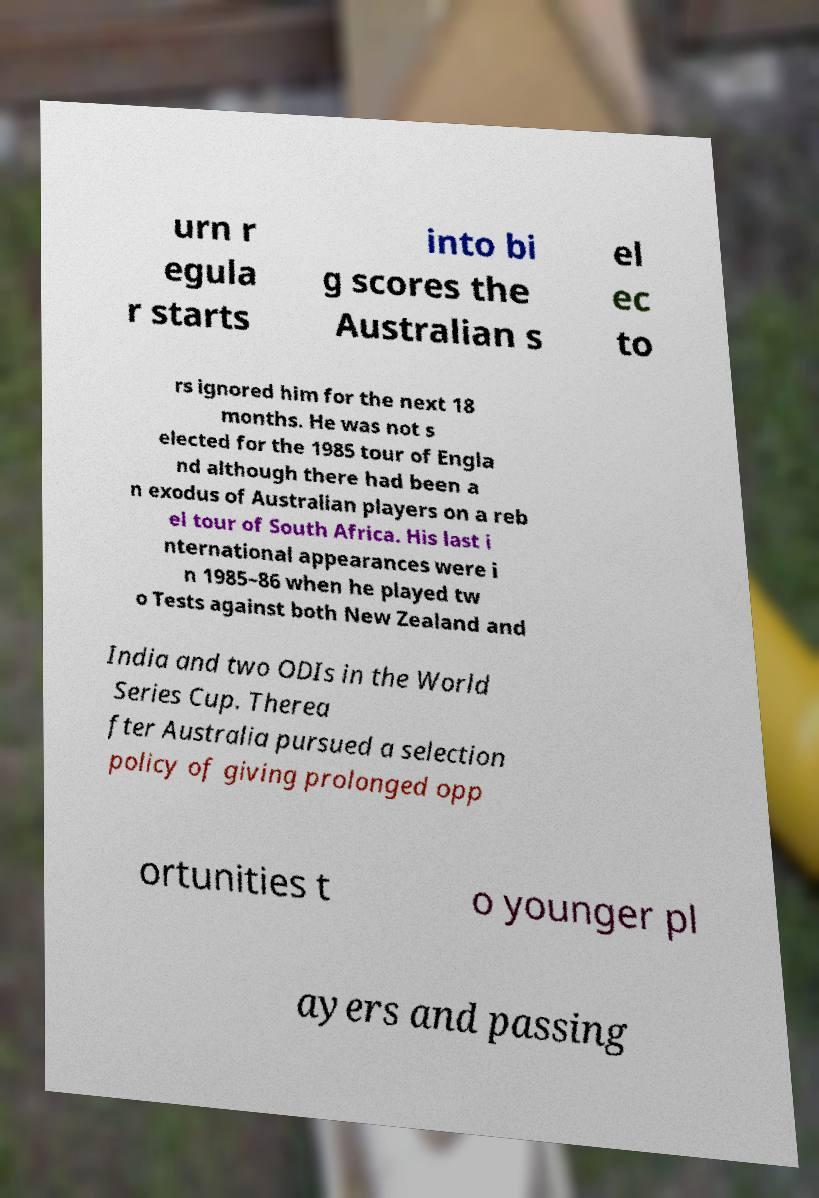Can you accurately transcribe the text from the provided image for me? urn r egula r starts into bi g scores the Australian s el ec to rs ignored him for the next 18 months. He was not s elected for the 1985 tour of Engla nd although there had been a n exodus of Australian players on a reb el tour of South Africa. His last i nternational appearances were i n 1985–86 when he played tw o Tests against both New Zealand and India and two ODIs in the World Series Cup. Therea fter Australia pursued a selection policy of giving prolonged opp ortunities t o younger pl ayers and passing 